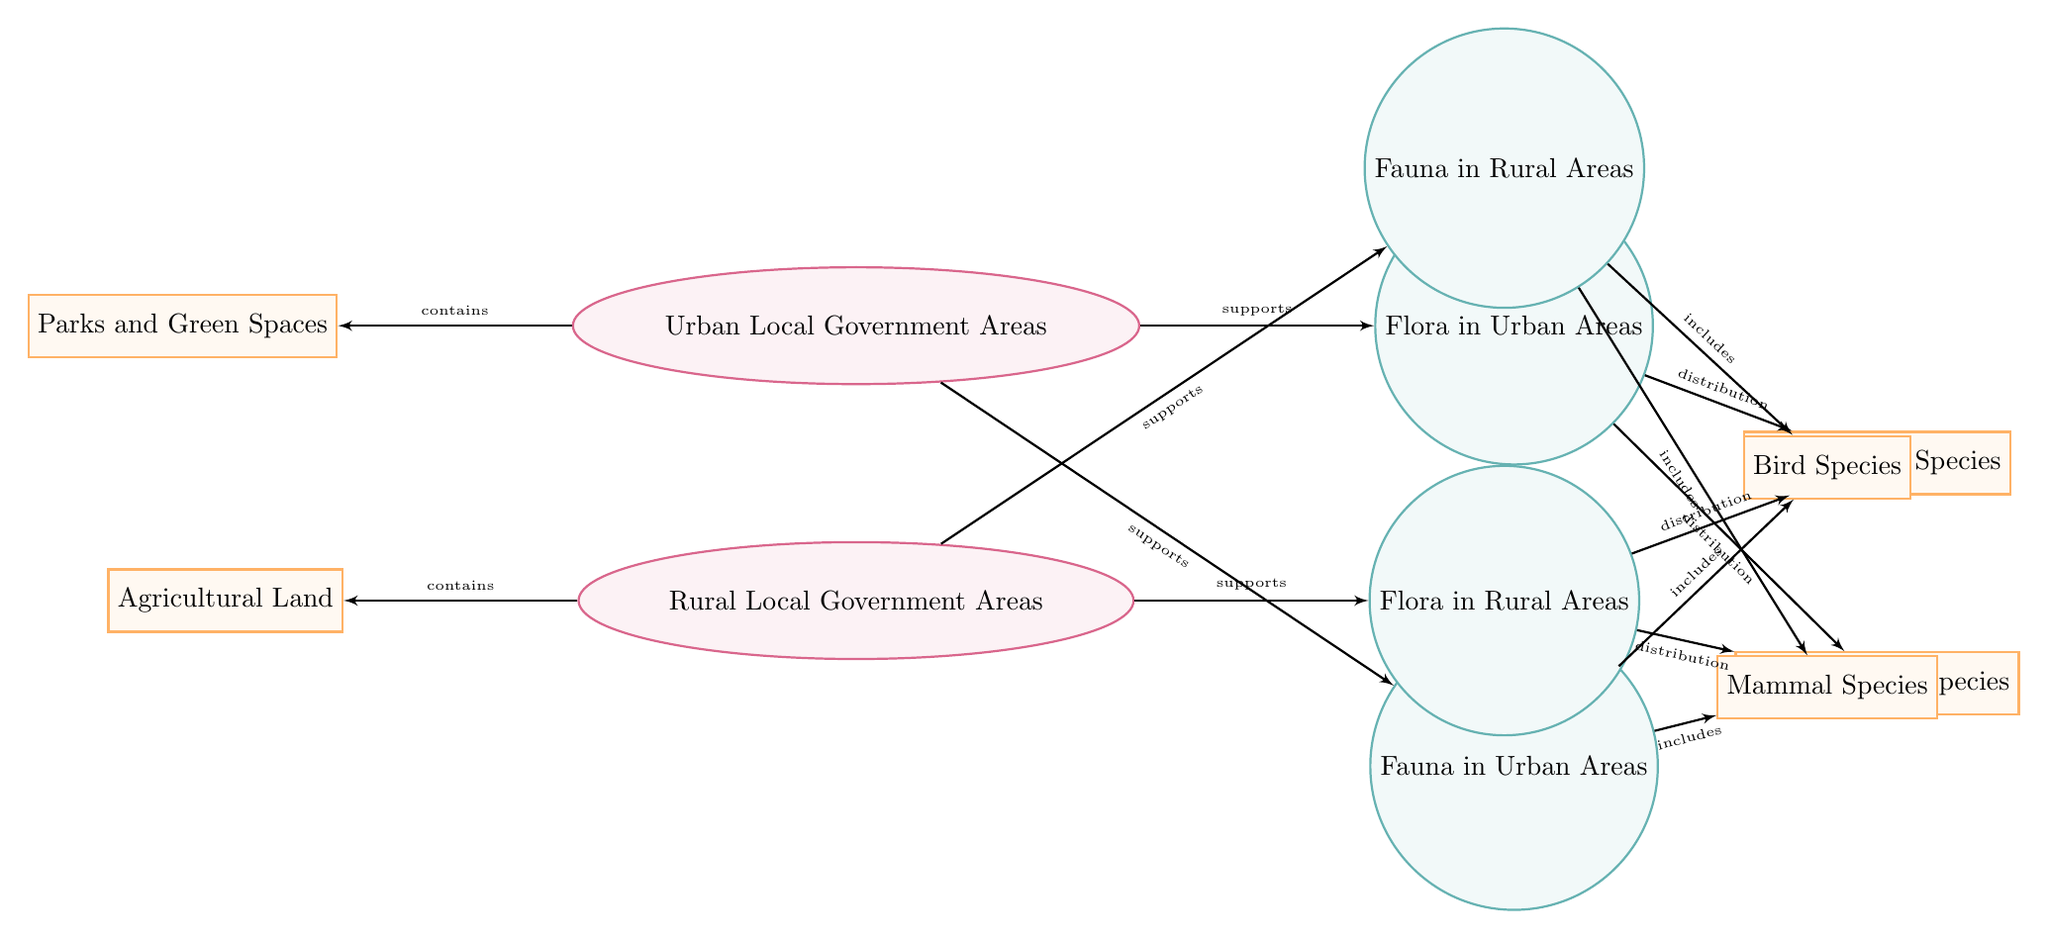What are the two main categories illustrated in the diagram? The diagram clearly presents two main categories: "Urban Local Government Areas" and "Rural Local Government Areas," which are visually represented at the top with an ellipse shape.
Answer: Urban Local Government Areas, Rural Local Government Areas How many species types are included in urban fauna? In the "Fauna in Urban Areas" section, there are two types listed: "Bird Species" and "Mammal Species," which are represented as main nodes below "Fauna in Urban Areas."
Answer: 2 What supports flora in urban areas? The arrow labeled "supports" leading from "Urban Local Government Areas" to "Flora in Urban Areas" indicates the support relationship, one of the foundational features in the diagram.
Answer: Urban Local Government Areas Which type of flora is distributed in rural areas according to the diagram? The diagram specifies two types of flora: "Native Plant Species" and "Invasive Plant Species," both connected to "Flora in Rural Areas" through distribution relationships shown.
Answer: Native Plant Species, Invasive Plant Species To what does "Fauna in Rural Areas" include? The relationships indicate that "Fauna in Rural Areas" includes "Bird Species" and "Mammal Species," represented through the edges leading to these sub-nodes.
Answer: Bird Species, Mammal Species What additional element does urban local government areas contain? The edge labeled "contains" shows that "Urban Local Government Areas" include "Parks and Green Spaces," indicating a specific attribute of urban environments captured in the diagram.
Answer: Parks and Green Spaces How many types of invasive plant species are displayed in the diagram? The diagram only mentions "Invasive Plant Species" as one category under both urban and rural flora, showing it is a single type represented within those areas.
Answer: 1 Which type of land is associated with rural local government areas? The diagram highlights "Agricultural Land" as a specific type of land associated with "Rural Local Government Areas," connected with an edge labeled "contains."
Answer: Agricultural Land What do urban areas primarily support according to the diagram? The diagram indicates that urban areas primarily support both "Flora in Urban Areas" and "Fauna in Urban Areas," showing a dual focus on plant and animal life within cities.
Answer: Flora in Urban Areas, Fauna in Urban Areas 